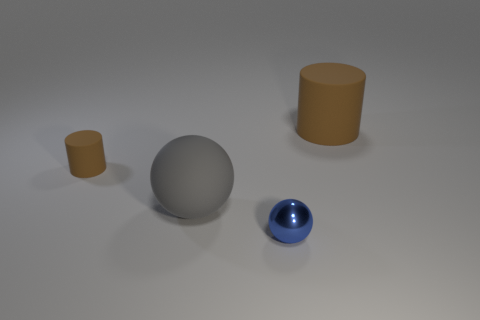Does the tiny cylinder have the same color as the big matte thing that is right of the blue thing?
Your answer should be compact. Yes. There is a small thing that is behind the gray rubber object; does it have the same color as the big rubber cylinder?
Make the answer very short. Yes. Are the gray ball and the tiny cylinder made of the same material?
Offer a terse response. Yes. Are there fewer small blue objects on the right side of the tiny blue metal ball than big purple rubber blocks?
Keep it short and to the point. No. Is the color of the large cylinder the same as the tiny matte object?
Make the answer very short. Yes. What size is the gray object?
Ensure brevity in your answer.  Large. What number of tiny metallic things have the same color as the tiny metallic ball?
Your answer should be very brief. 0. Is there a big gray thing on the right side of the brown cylinder to the right of the sphere that is to the right of the big gray sphere?
Give a very brief answer. No. There is a brown matte thing that is the same size as the blue ball; what is its shape?
Offer a very short reply. Cylinder. How many big objects are either blue metal blocks or metal objects?
Offer a terse response. 0. 